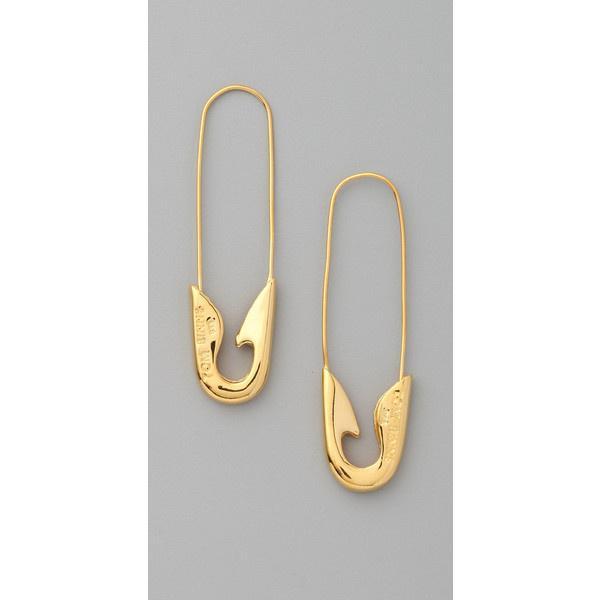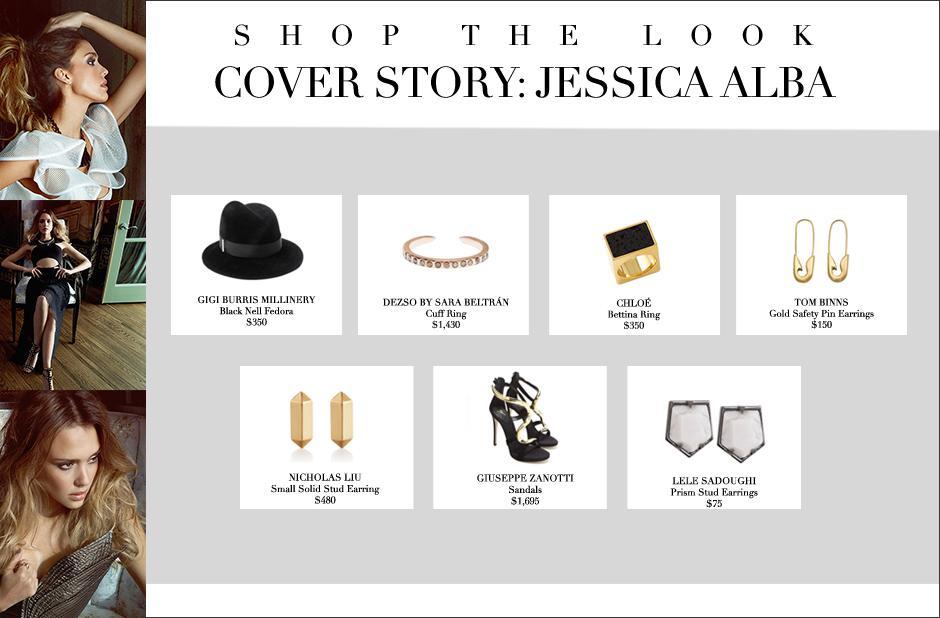The first image is the image on the left, the second image is the image on the right. Considering the images on both sides, is "At least one image includes a pair of closed, unembellished gold safety pins displayed with the clasp end downward." valid? Answer yes or no. Yes. 